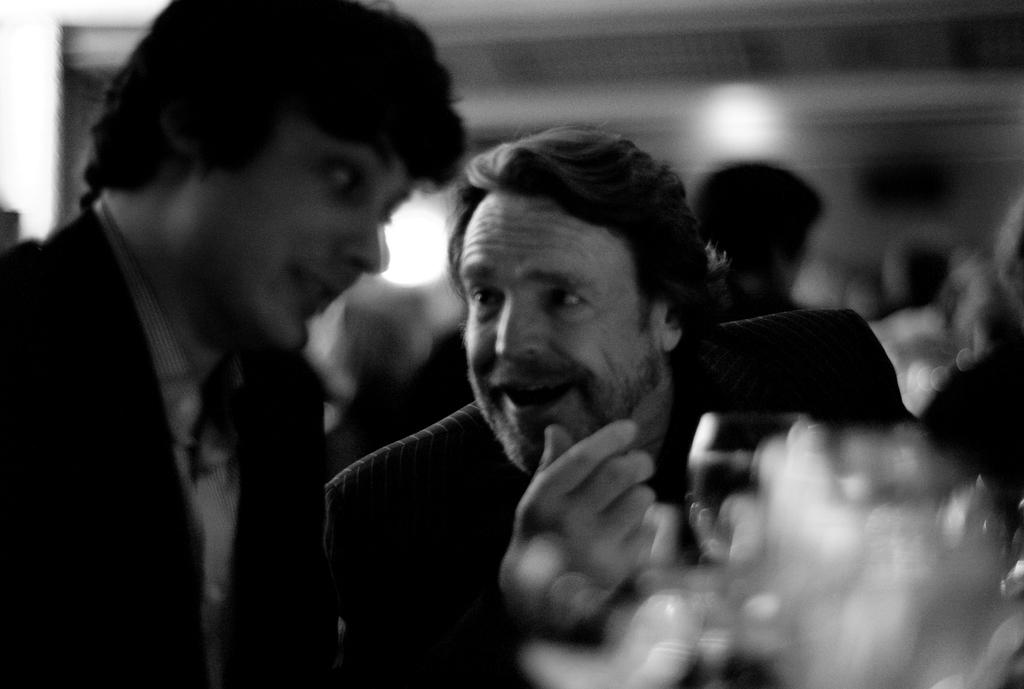What is the color scheme of the image? The image is black and white. How many men are sitting in the front? There are two men sitting in the front. What are the men holding on the table? The men have wine glasses on the table. Can you describe the presence of other people in the image? There are additional people visible in the background. How does the cow contribute to the heat in the image? There is no cow present in the image, so it cannot contribute to the heat. 